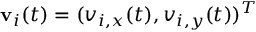Convert formula to latex. <formula><loc_0><loc_0><loc_500><loc_500>\mathbf v _ { i } ( t ) = ( v _ { i , x } ( t ) , v _ { i , y } ( t ) ) ^ { T }</formula> 